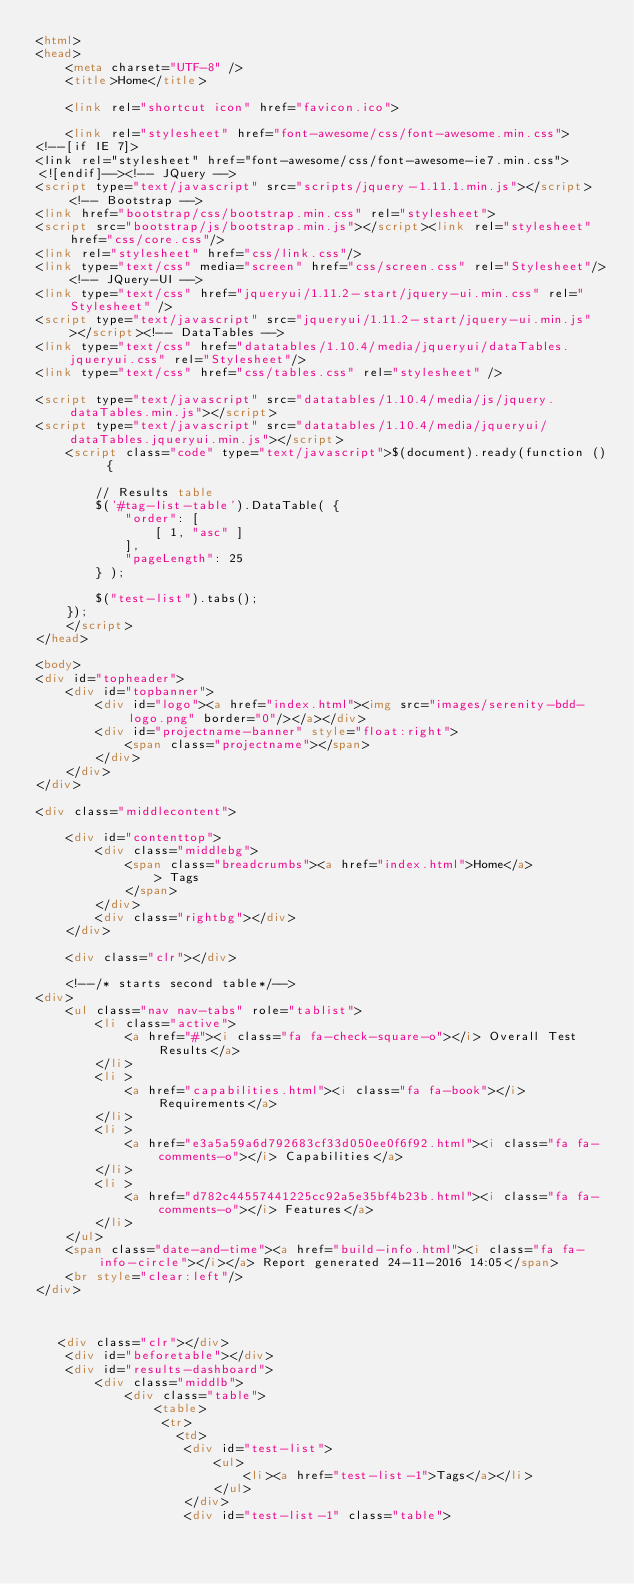<code> <loc_0><loc_0><loc_500><loc_500><_HTML_><html>
<head>
    <meta charset="UTF-8" />
    <title>Home</title>

    <link rel="shortcut icon" href="favicon.ico">

    <link rel="stylesheet" href="font-awesome/css/font-awesome.min.css">
<!--[if IE 7]>
<link rel="stylesheet" href="font-awesome/css/font-awesome-ie7.min.css">
<![endif]--><!-- JQuery -->
<script type="text/javascript" src="scripts/jquery-1.11.1.min.js"></script><!-- Bootstrap -->
<link href="bootstrap/css/bootstrap.min.css" rel="stylesheet">
<script src="bootstrap/js/bootstrap.min.js"></script><link rel="stylesheet" href="css/core.css"/>
<link rel="stylesheet" href="css/link.css"/>
<link type="text/css" media="screen" href="css/screen.css" rel="Stylesheet"/><!-- JQuery-UI -->
<link type="text/css" href="jqueryui/1.11.2-start/jquery-ui.min.css" rel="Stylesheet" />
<script type="text/javascript" src="jqueryui/1.11.2-start/jquery-ui.min.js"></script><!-- DataTables -->
<link type="text/css" href="datatables/1.10.4/media/jqueryui/dataTables.jqueryui.css" rel="Stylesheet"/>
<link type="text/css" href="css/tables.css" rel="stylesheet" />

<script type="text/javascript" src="datatables/1.10.4/media/js/jquery.dataTables.min.js"></script>
<script type="text/javascript" src="datatables/1.10.4/media/jqueryui/dataTables.jqueryui.min.js"></script>
    <script class="code" type="text/javascript">$(document).ready(function () {

        // Results table
        $('#tag-list-table').DataTable( {
            "order": [
                [ 1, "asc" ]
            ],
            "pageLength": 25
        } );

        $("test-list").tabs();
    });
    </script>
</head>

<body>
<div id="topheader">
    <div id="topbanner">
        <div id="logo"><a href="index.html"><img src="images/serenity-bdd-logo.png" border="0"/></a></div>
        <div id="projectname-banner" style="float:right">
            <span class="projectname"></span>
        </div>
    </div>
</div>

<div class="middlecontent">

    <div id="contenttop">
        <div class="middlebg">
            <span class="breadcrumbs"><a href="index.html">Home</a> 
                > Tags
            </span>
        </div>
        <div class="rightbg"></div>
    </div>

    <div class="clr"></div>

    <!--/* starts second table*/-->
<div>
    <ul class="nav nav-tabs" role="tablist">
        <li class="active">
            <a href="#"><i class="fa fa-check-square-o"></i> Overall Test Results</a>
        </li>
        <li >
            <a href="capabilities.html"><i class="fa fa-book"></i> Requirements</a>
        </li>
        <li >
            <a href="e3a5a59a6d792683cf33d050ee0f6f92.html"><i class="fa fa-comments-o"></i> Capabilities</a>
        </li>
        <li >
            <a href="d782c44557441225cc92a5e35bf4b23b.html"><i class="fa fa-comments-o"></i> Features</a>
        </li>
    </ul>
    <span class="date-and-time"><a href="build-info.html"><i class="fa fa-info-circle"></i></a> Report generated 24-11-2016 14:05</span>
    <br style="clear:left"/>
</div>



   <div class="clr"></div>
    <div id="beforetable"></div>
    <div id="results-dashboard">
        <div class="middlb">
            <div class="table">
                <table>
                 <tr>
                   <td>
                    <div id="test-list">
                        <ul>
                            <li><a href="test-list-1">Tags</a></li>
                        </ul>
                    </div>
                    <div id="test-list-1" class="table"></code> 